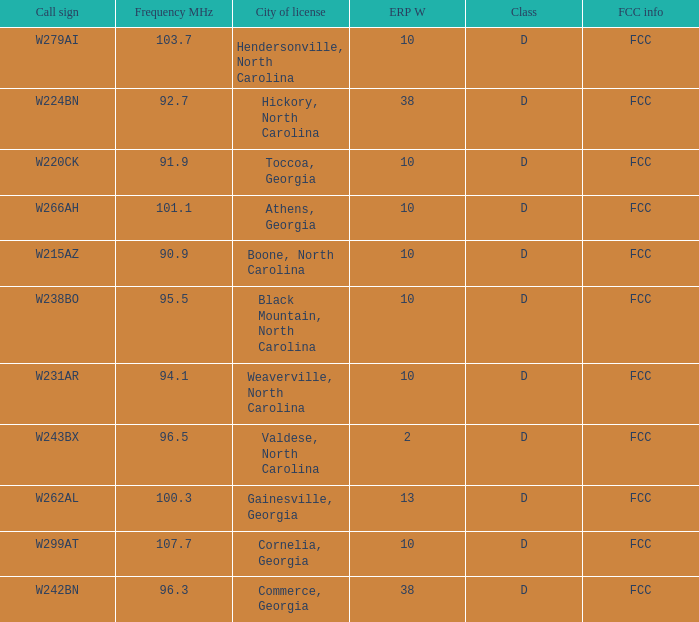What is the FCC frequency for the station w262al which has a Frequency MHz larger than 92.7? FCC. 